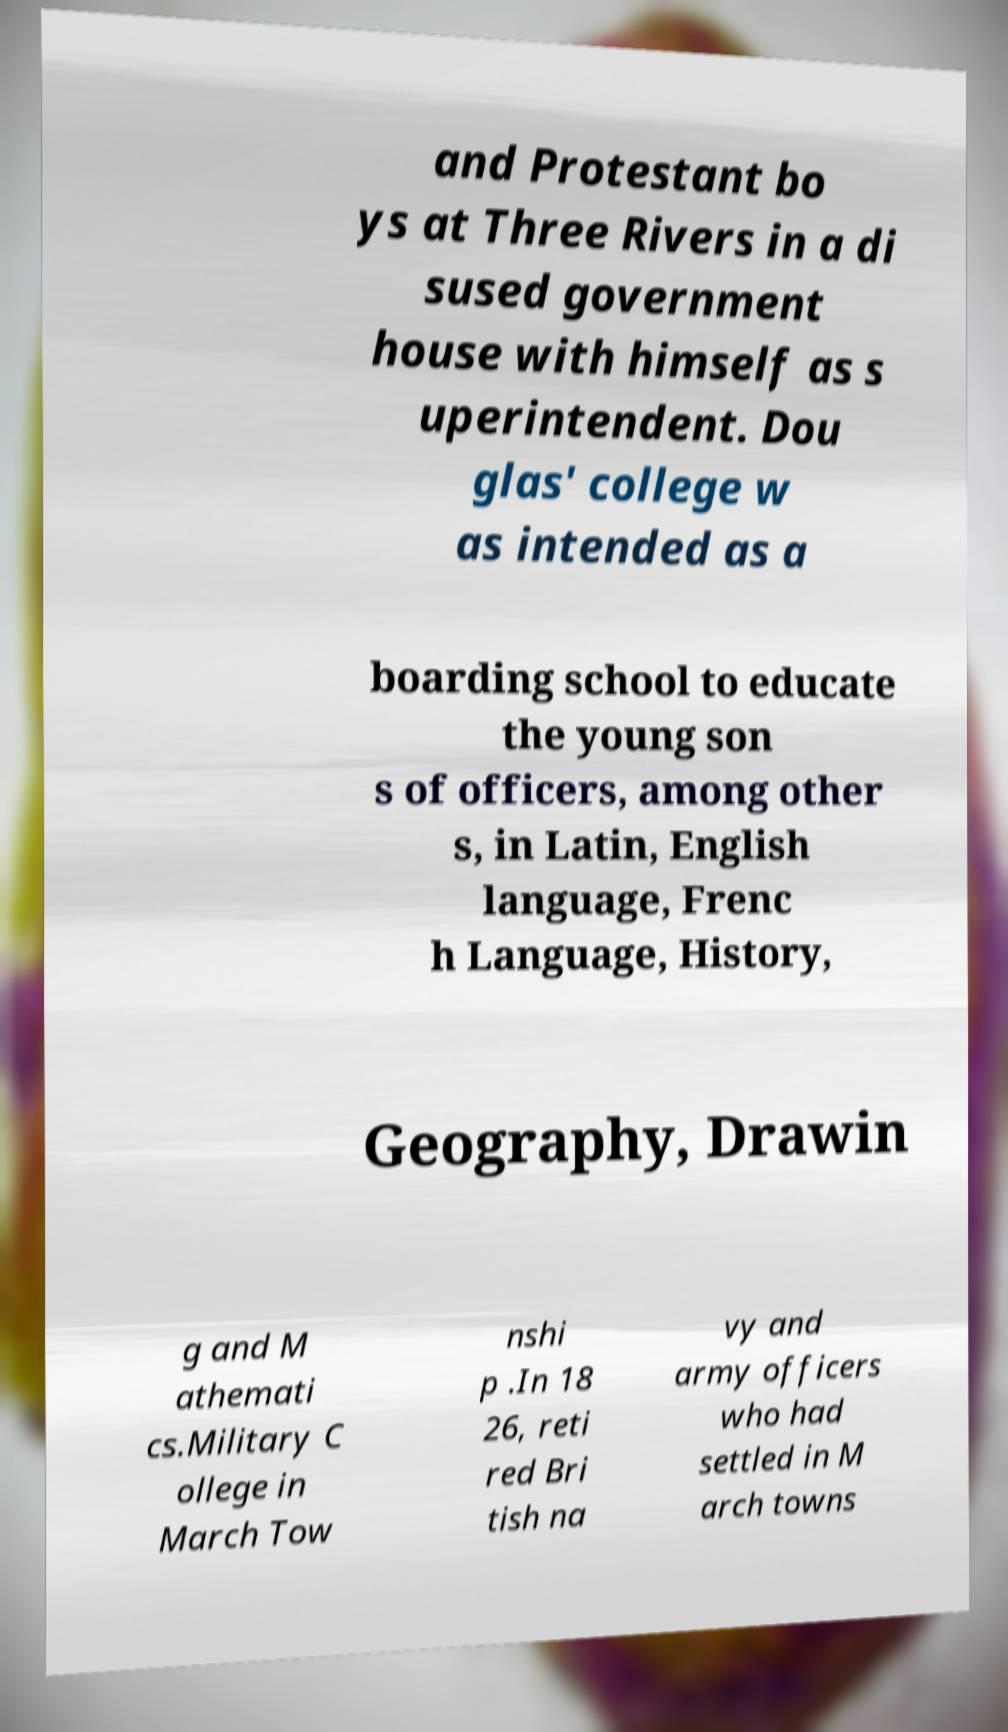Could you assist in decoding the text presented in this image and type it out clearly? and Protestant bo ys at Three Rivers in a di sused government house with himself as s uperintendent. Dou glas' college w as intended as a boarding school to educate the young son s of officers, among other s, in Latin, English language, Frenc h Language, History, Geography, Drawin g and M athemati cs.Military C ollege in March Tow nshi p .In 18 26, reti red Bri tish na vy and army officers who had settled in M arch towns 